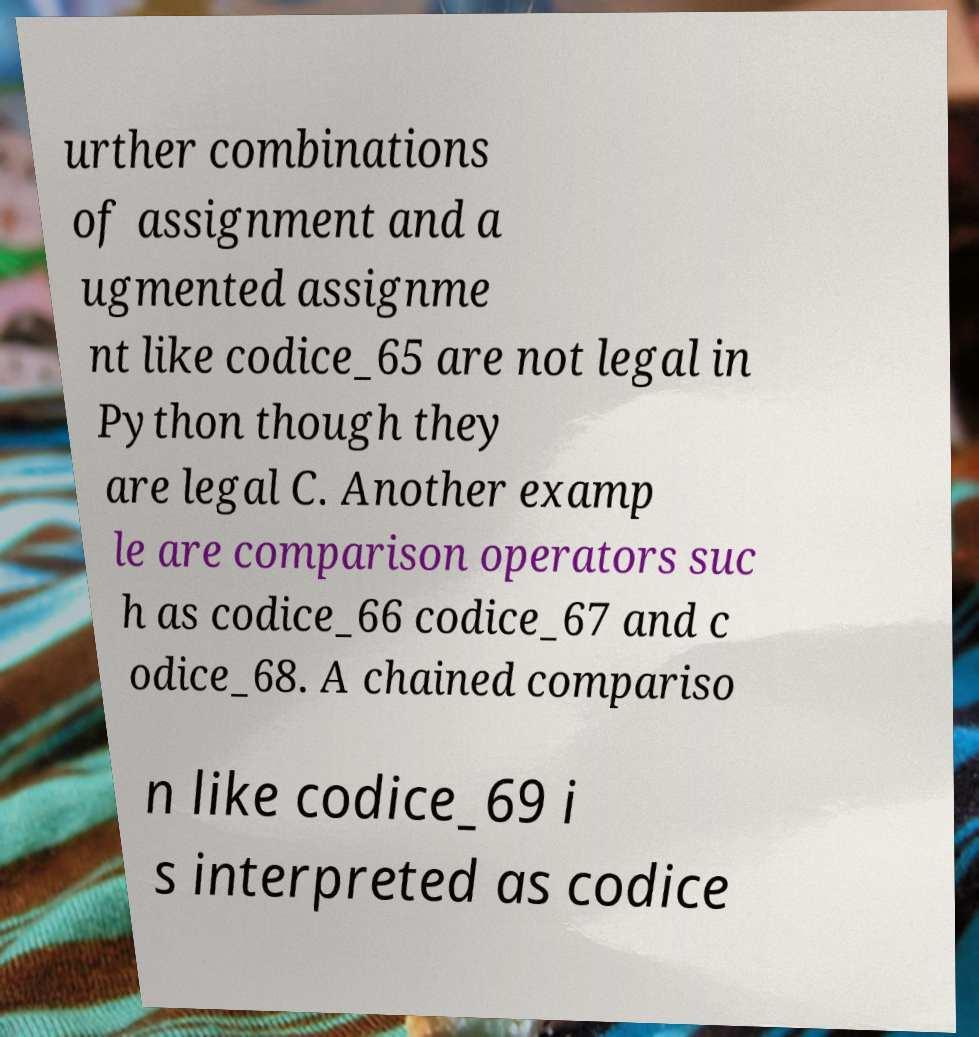Can you read and provide the text displayed in the image?This photo seems to have some interesting text. Can you extract and type it out for me? urther combinations of assignment and a ugmented assignme nt like codice_65 are not legal in Python though they are legal C. Another examp le are comparison operators suc h as codice_66 codice_67 and c odice_68. A chained compariso n like codice_69 i s interpreted as codice 